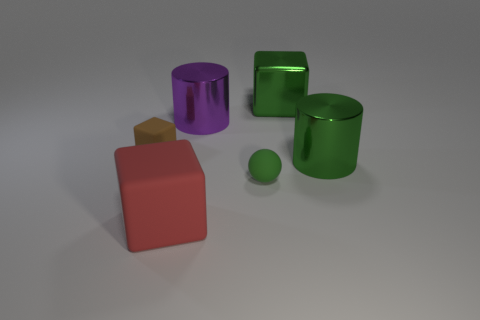Subtract 1 cubes. How many cubes are left? 2 Add 1 big brown matte cylinders. How many objects exist? 7 Subtract all balls. How many objects are left? 5 Add 5 green cylinders. How many green cylinders are left? 6 Add 4 small blue matte things. How many small blue matte things exist? 4 Subtract 0 blue cylinders. How many objects are left? 6 Subtract all large brown cylinders. Subtract all large metal cylinders. How many objects are left? 4 